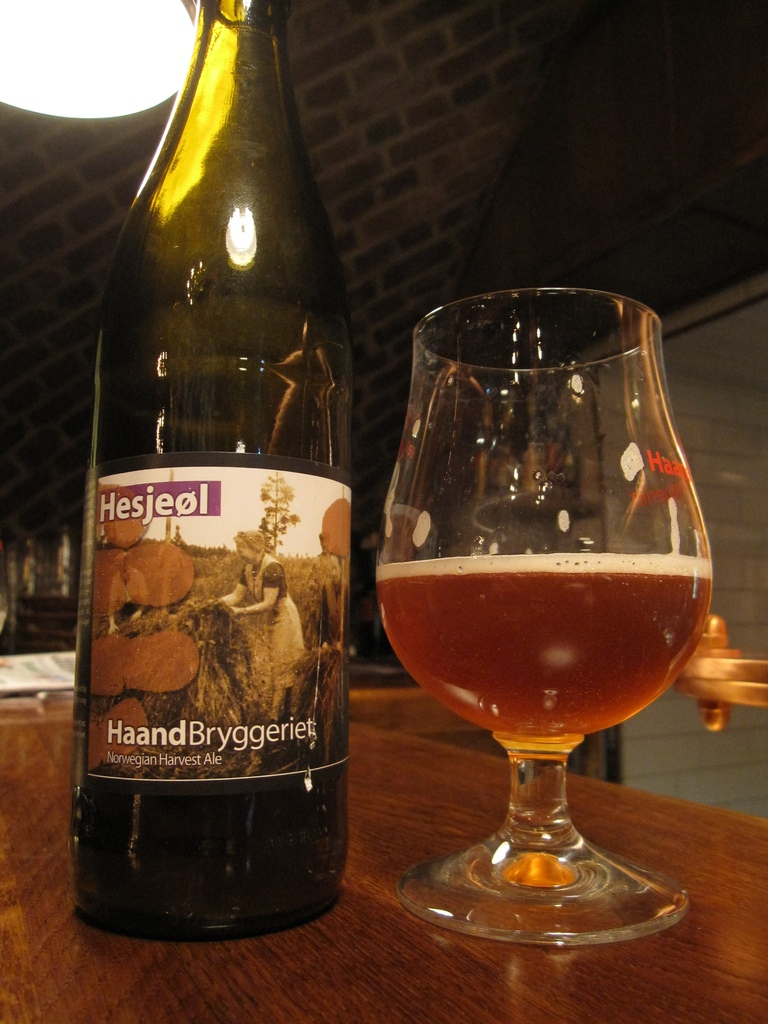Provide a one-sentence caption for the provided image. Under the warm glow of indoor lighting, a bottle of Hesjeol, a Norwegian Harvest Ale from HaandBryggeriet, stands next to a snifter almost half full, showcasing its rich amber hue. 